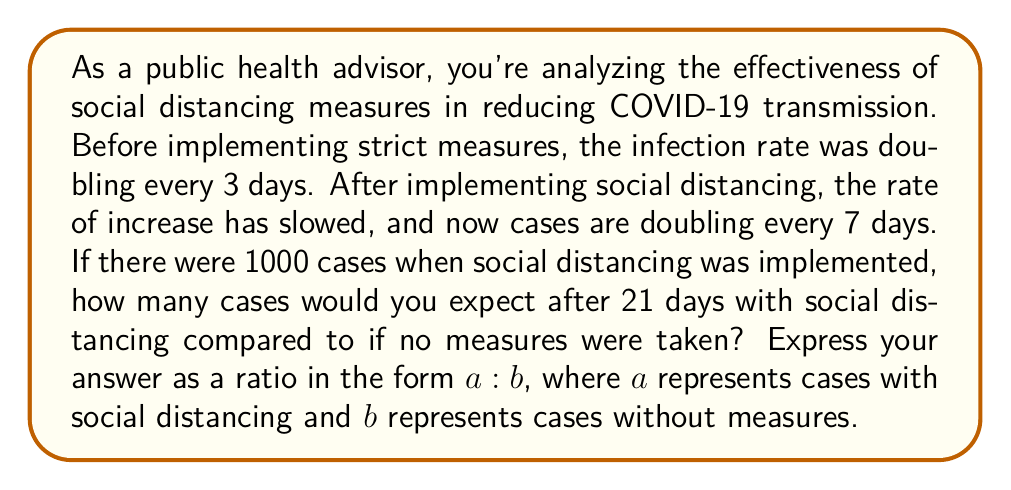What is the answer to this math problem? Let's approach this step-by-step:

1) First, let's calculate the number of cases after 21 days with social distancing:
   - Cases double every 7 days
   - In 21 days, there are 3 doubling periods (21 ÷ 7 = 3)
   - Starting with 1000 cases, we can represent this as:
     $$ 1000 \cdot 2^3 = 1000 \cdot 8 = 8000 \text{ cases} $$

2) Now, let's calculate the number of cases after 21 days without social distancing:
   - Cases double every 3 days
   - In 21 days, there are 7 doubling periods (21 ÷ 3 = 7)
   - Starting with 1000 cases, we can represent this as:
     $$ 1000 \cdot 2^7 = 1000 \cdot 128 = 128000 \text{ cases} $$

3) To express this as a ratio, we put the number of cases with social distancing over the number without:
   $$ \frac{8000}{128000} = \frac{1}{16} $$

4) This can be expressed as the ratio 1:16

This ratio shows that for every 1 case with social distancing, there would be 16 cases without these measures, demonstrating the significant impact of social distancing on reducing infection rates.
Answer: 1:16 